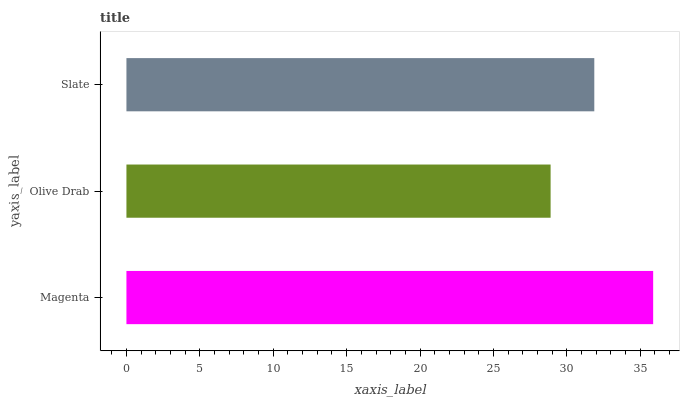Is Olive Drab the minimum?
Answer yes or no. Yes. Is Magenta the maximum?
Answer yes or no. Yes. Is Slate the minimum?
Answer yes or no. No. Is Slate the maximum?
Answer yes or no. No. Is Slate greater than Olive Drab?
Answer yes or no. Yes. Is Olive Drab less than Slate?
Answer yes or no. Yes. Is Olive Drab greater than Slate?
Answer yes or no. No. Is Slate less than Olive Drab?
Answer yes or no. No. Is Slate the high median?
Answer yes or no. Yes. Is Slate the low median?
Answer yes or no. Yes. Is Magenta the high median?
Answer yes or no. No. Is Olive Drab the low median?
Answer yes or no. No. 